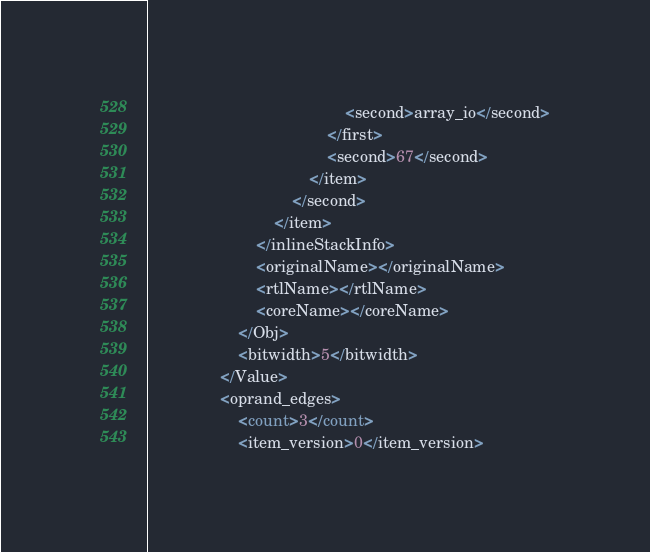Convert code to text. <code><loc_0><loc_0><loc_500><loc_500><_Ada_>											<second>array_io</second>
										</first>
										<second>67</second>
									</item>
								</second>
							</item>
						</inlineStackInfo>
						<originalName></originalName>
						<rtlName></rtlName>
						<coreName></coreName>
					</Obj>
					<bitwidth>5</bitwidth>
				</Value>
				<oprand_edges>
					<count>3</count>
					<item_version>0</item_version></code> 